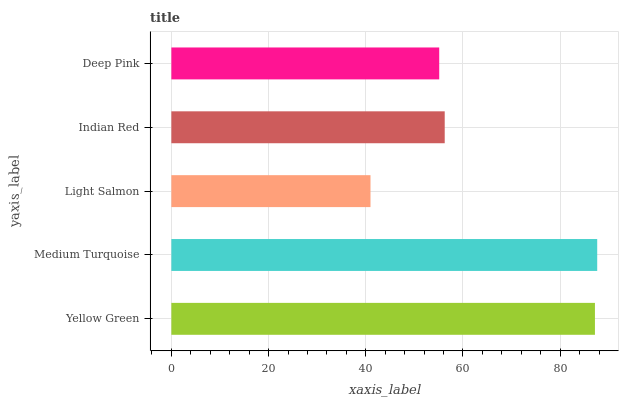Is Light Salmon the minimum?
Answer yes or no. Yes. Is Medium Turquoise the maximum?
Answer yes or no. Yes. Is Medium Turquoise the minimum?
Answer yes or no. No. Is Light Salmon the maximum?
Answer yes or no. No. Is Medium Turquoise greater than Light Salmon?
Answer yes or no. Yes. Is Light Salmon less than Medium Turquoise?
Answer yes or no. Yes. Is Light Salmon greater than Medium Turquoise?
Answer yes or no. No. Is Medium Turquoise less than Light Salmon?
Answer yes or no. No. Is Indian Red the high median?
Answer yes or no. Yes. Is Indian Red the low median?
Answer yes or no. Yes. Is Light Salmon the high median?
Answer yes or no. No. Is Light Salmon the low median?
Answer yes or no. No. 